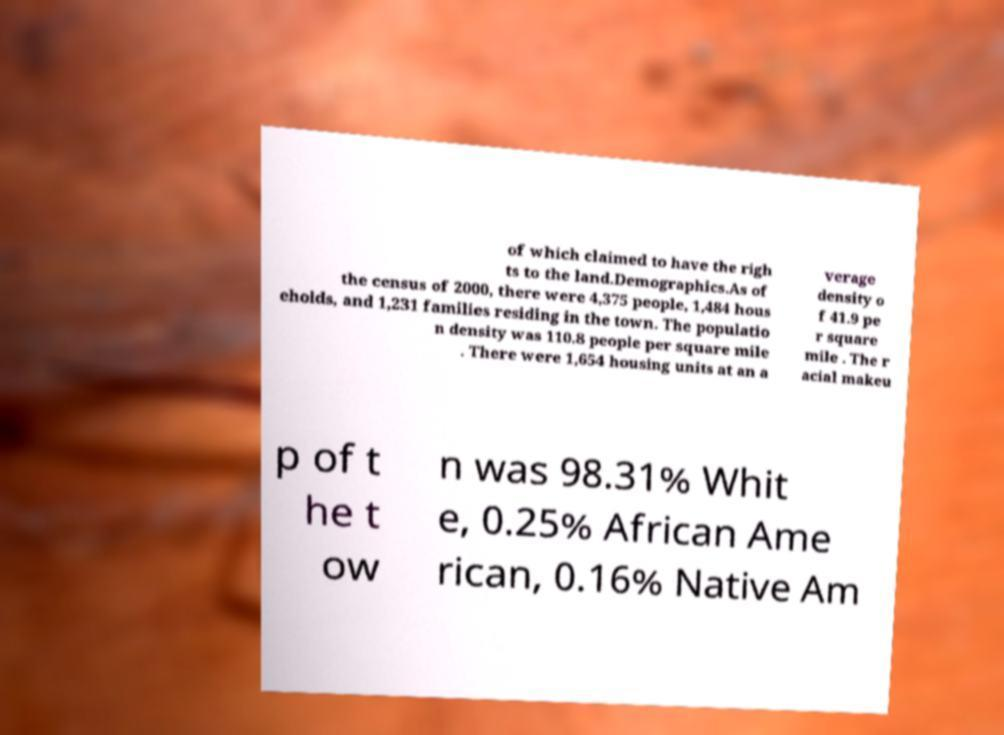What messages or text are displayed in this image? I need them in a readable, typed format. of which claimed to have the righ ts to the land.Demographics.As of the census of 2000, there were 4,375 people, 1,484 hous eholds, and 1,231 families residing in the town. The populatio n density was 110.8 people per square mile . There were 1,654 housing units at an a verage density o f 41.9 pe r square mile . The r acial makeu p of t he t ow n was 98.31% Whit e, 0.25% African Ame rican, 0.16% Native Am 